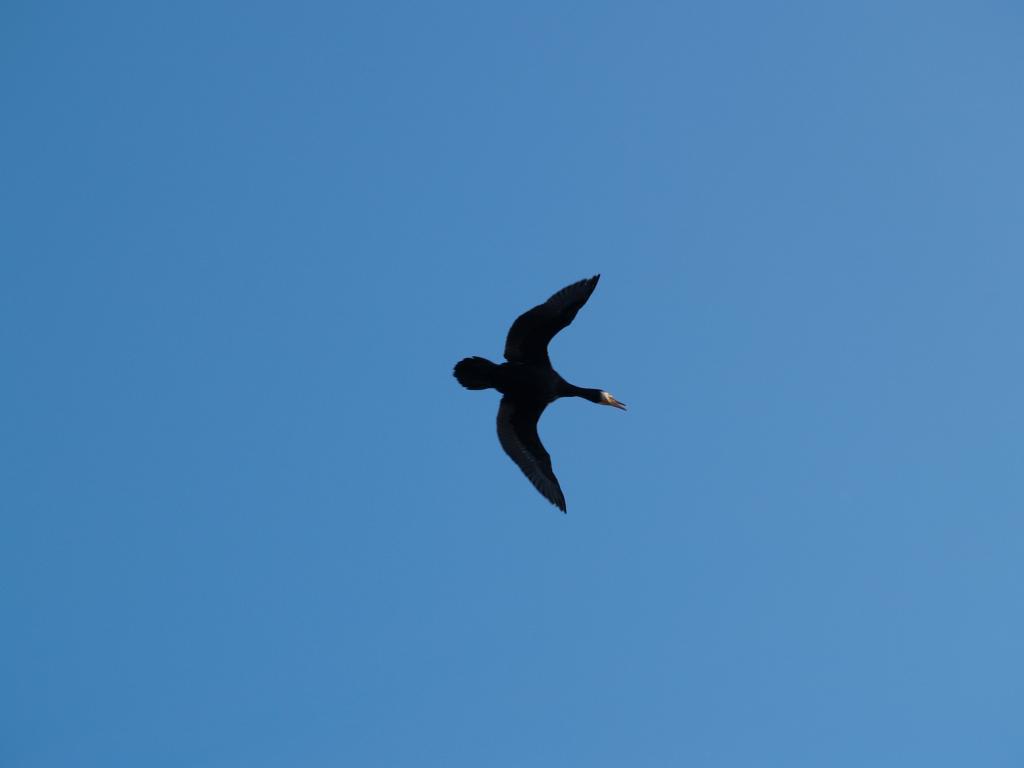Please provide a concise description of this image. In this image I can see a bird which is black in color is flying in the air and in the background I can see the sky which is blue in color. 